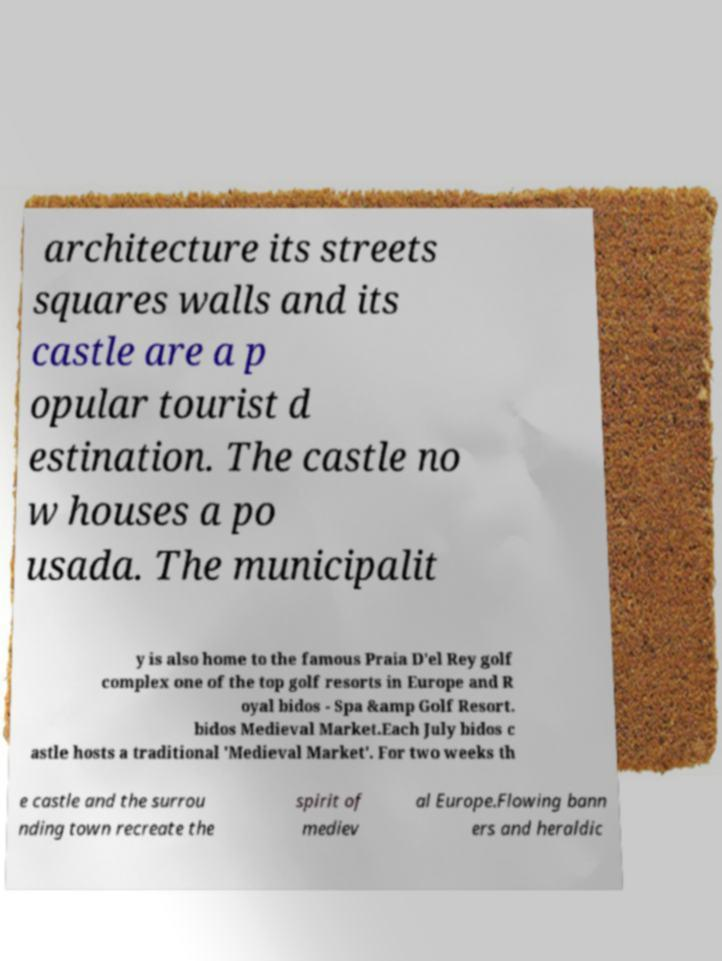Please read and relay the text visible in this image. What does it say? architecture its streets squares walls and its castle are a p opular tourist d estination. The castle no w houses a po usada. The municipalit y is also home to the famous Praia D'el Rey golf complex one of the top golf resorts in Europe and R oyal bidos - Spa &amp Golf Resort. bidos Medieval Market.Each July bidos c astle hosts a traditional 'Medieval Market'. For two weeks th e castle and the surrou nding town recreate the spirit of mediev al Europe.Flowing bann ers and heraldic 